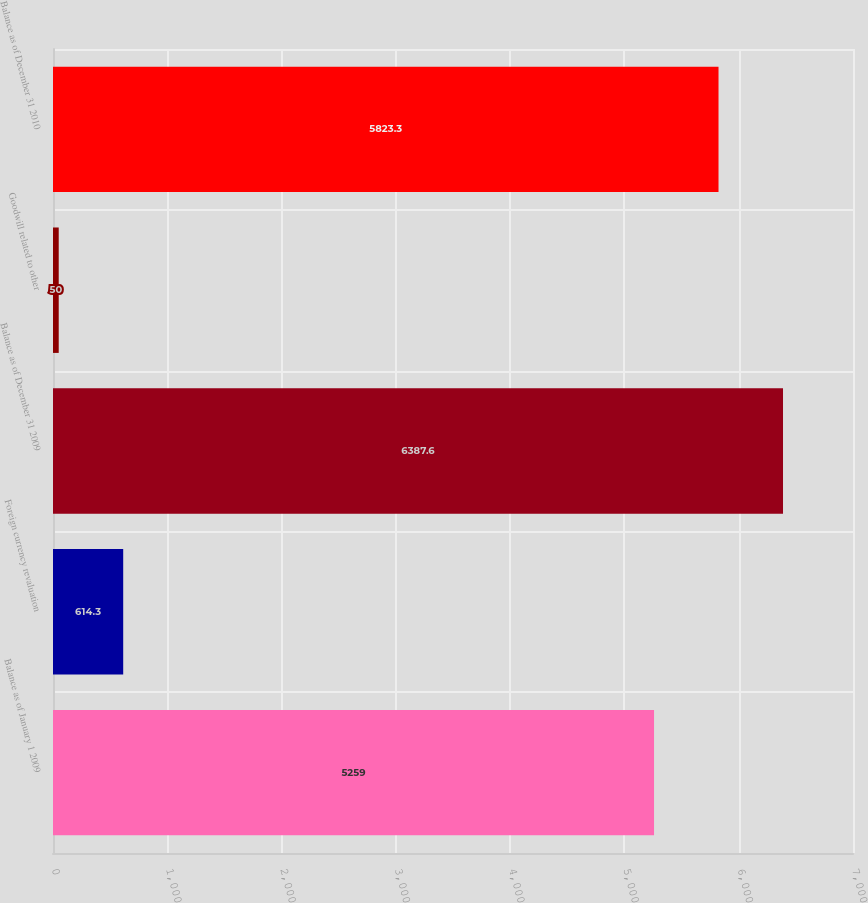<chart> <loc_0><loc_0><loc_500><loc_500><bar_chart><fcel>Balance as of January 1 2009<fcel>Foreign currency revaluation<fcel>Balance as of December 31 2009<fcel>Goodwill related to other<fcel>Balance as of December 31 2010<nl><fcel>5259<fcel>614.3<fcel>6387.6<fcel>50<fcel>5823.3<nl></chart> 